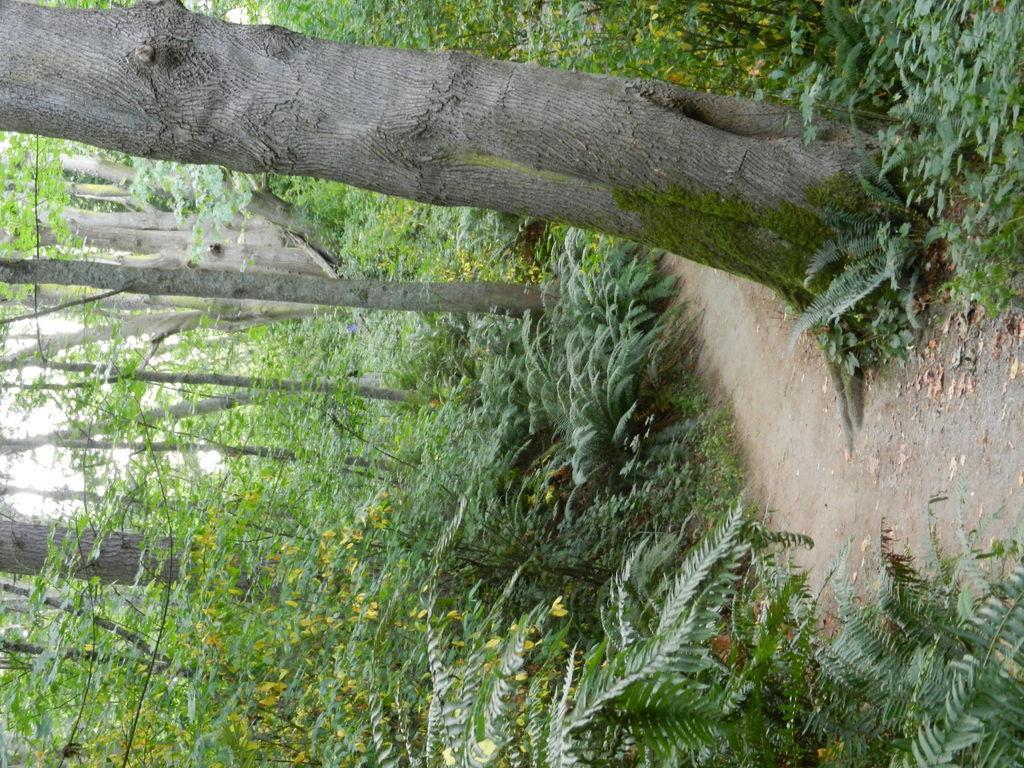How would you summarize this image in a sentence or two? In the picture we can see the surface with plants and trees and near it, we can see a part of the muddy surface and from the trees we can see the part of the sky. 